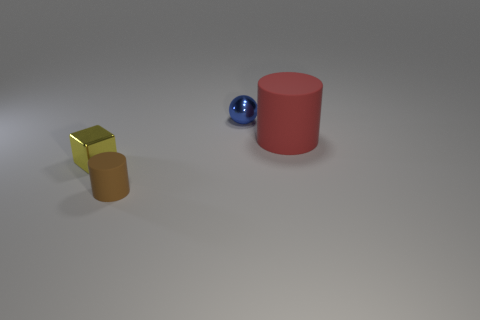Add 2 brown objects. How many objects exist? 6 Subtract all blocks. How many objects are left? 3 Subtract 1 yellow blocks. How many objects are left? 3 Subtract all tiny blue balls. Subtract all tiny blue metal balls. How many objects are left? 2 Add 4 brown objects. How many brown objects are left? 5 Add 1 big green matte blocks. How many big green matte blocks exist? 1 